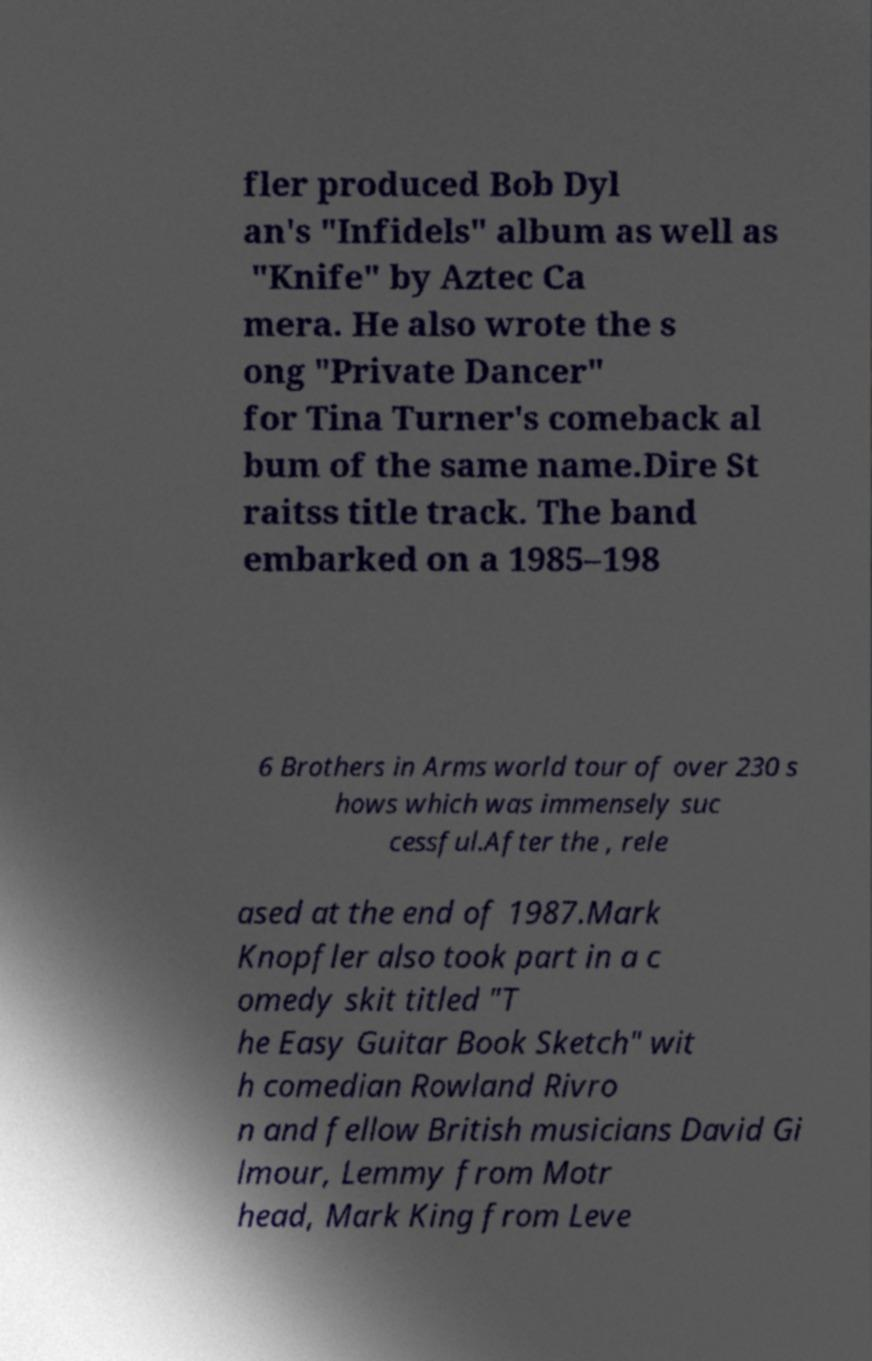Could you extract and type out the text from this image? fler produced Bob Dyl an's "Infidels" album as well as "Knife" by Aztec Ca mera. He also wrote the s ong "Private Dancer" for Tina Turner's comeback al bum of the same name.Dire St raitss title track. The band embarked on a 1985–198 6 Brothers in Arms world tour of over 230 s hows which was immensely suc cessful.After the , rele ased at the end of 1987.Mark Knopfler also took part in a c omedy skit titled "T he Easy Guitar Book Sketch" wit h comedian Rowland Rivro n and fellow British musicians David Gi lmour, Lemmy from Motr head, Mark King from Leve 